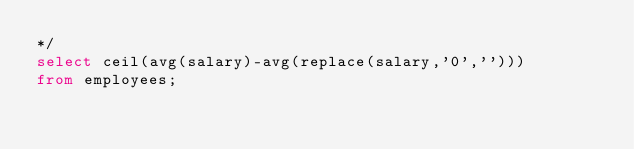Convert code to text. <code><loc_0><loc_0><loc_500><loc_500><_SQL_>*/
select ceil(avg(salary)-avg(replace(salary,'0','')))
from employees;</code> 